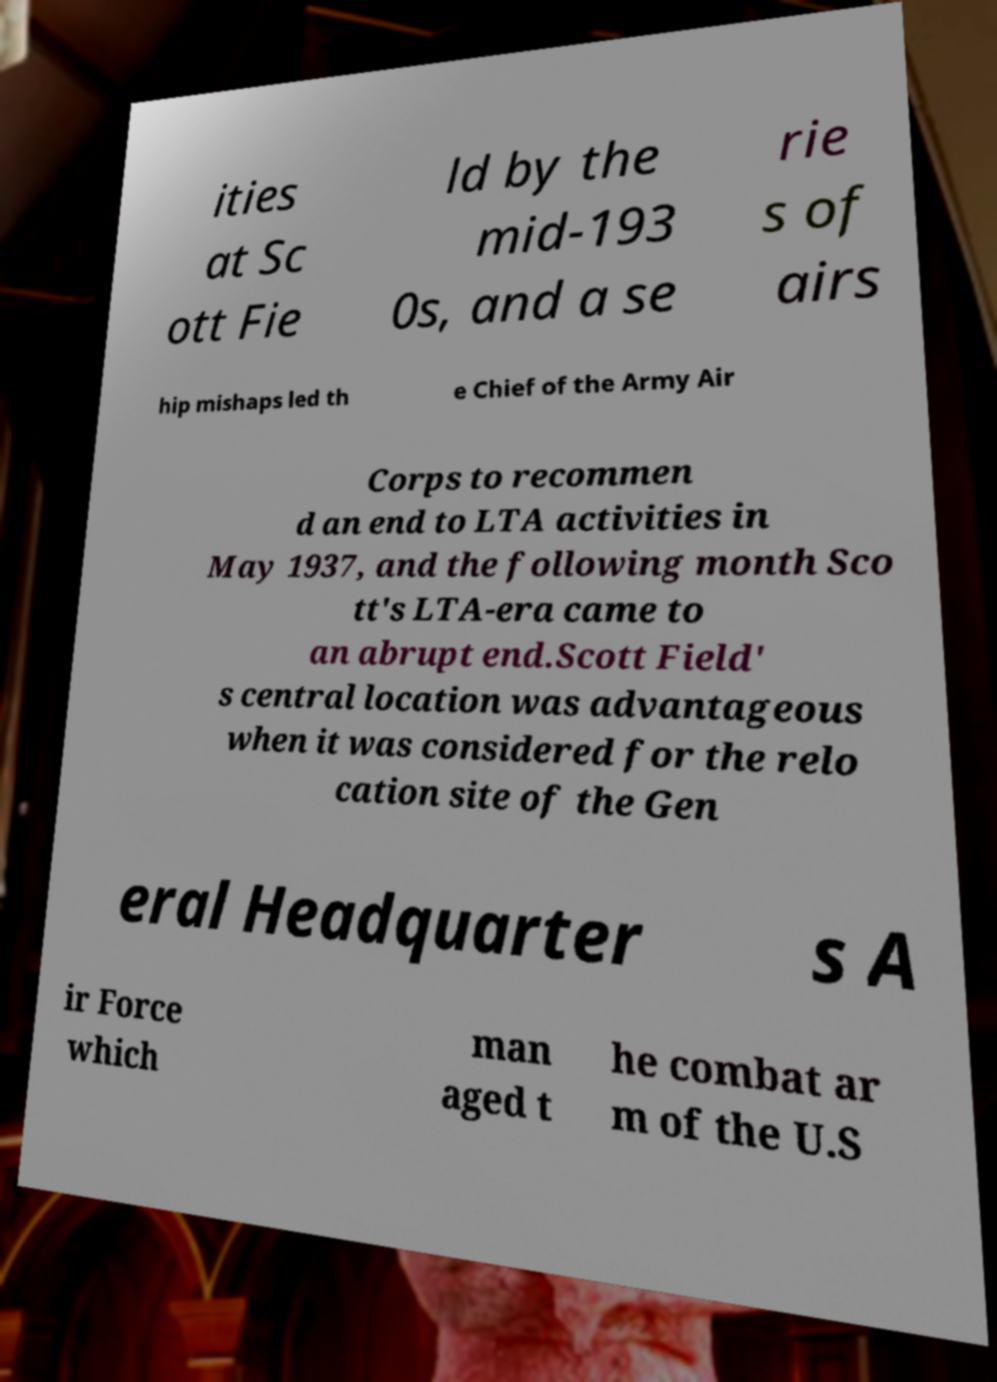What messages or text are displayed in this image? I need them in a readable, typed format. ities at Sc ott Fie ld by the mid-193 0s, and a se rie s of airs hip mishaps led th e Chief of the Army Air Corps to recommen d an end to LTA activities in May 1937, and the following month Sco tt's LTA-era came to an abrupt end.Scott Field' s central location was advantageous when it was considered for the relo cation site of the Gen eral Headquarter s A ir Force which man aged t he combat ar m of the U.S 